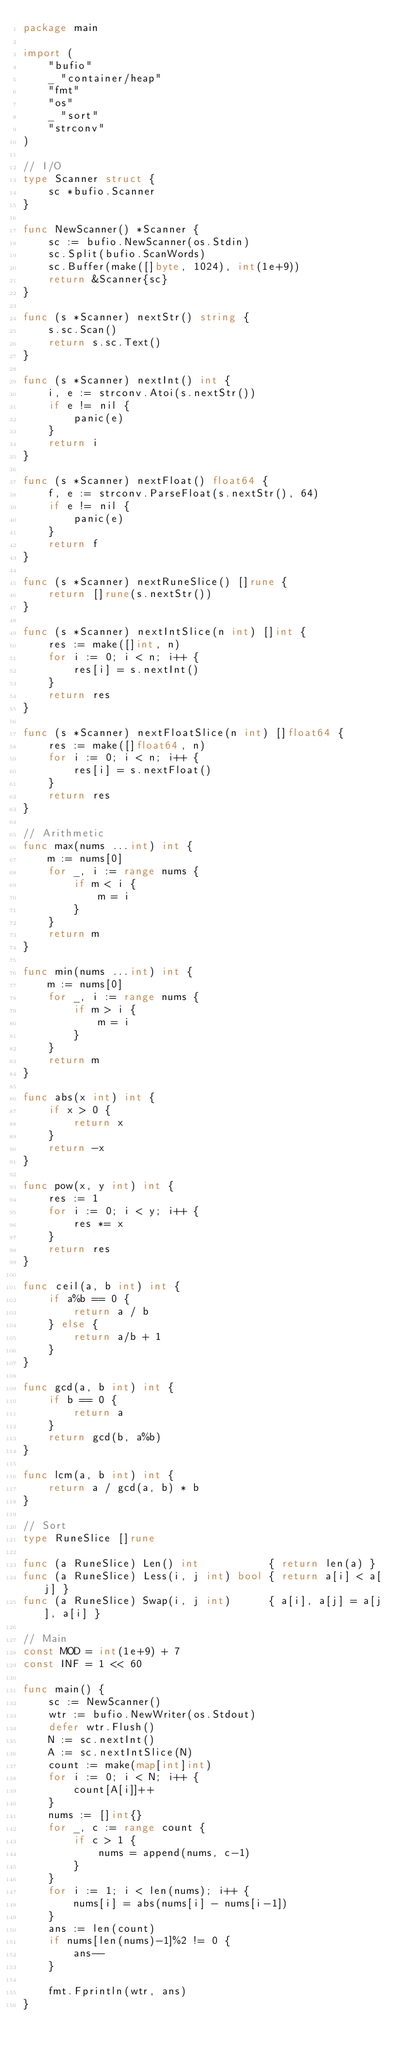<code> <loc_0><loc_0><loc_500><loc_500><_Go_>package main

import (
	"bufio"
	_ "container/heap"
	"fmt"
	"os"
	_ "sort"
	"strconv"
)

// I/O
type Scanner struct {
	sc *bufio.Scanner
}

func NewScanner() *Scanner {
	sc := bufio.NewScanner(os.Stdin)
	sc.Split(bufio.ScanWords)
	sc.Buffer(make([]byte, 1024), int(1e+9))
	return &Scanner{sc}
}

func (s *Scanner) nextStr() string {
	s.sc.Scan()
	return s.sc.Text()
}

func (s *Scanner) nextInt() int {
	i, e := strconv.Atoi(s.nextStr())
	if e != nil {
		panic(e)
	}
	return i
}

func (s *Scanner) nextFloat() float64 {
	f, e := strconv.ParseFloat(s.nextStr(), 64)
	if e != nil {
		panic(e)
	}
	return f
}

func (s *Scanner) nextRuneSlice() []rune {
	return []rune(s.nextStr())
}

func (s *Scanner) nextIntSlice(n int) []int {
	res := make([]int, n)
	for i := 0; i < n; i++ {
		res[i] = s.nextInt()
	}
	return res
}

func (s *Scanner) nextFloatSlice(n int) []float64 {
	res := make([]float64, n)
	for i := 0; i < n; i++ {
		res[i] = s.nextFloat()
	}
	return res
}

// Arithmetic
func max(nums ...int) int {
	m := nums[0]
	for _, i := range nums {
		if m < i {
			m = i
		}
	}
	return m
}

func min(nums ...int) int {
	m := nums[0]
	for _, i := range nums {
		if m > i {
			m = i
		}
	}
	return m
}

func abs(x int) int {
	if x > 0 {
		return x
	}
	return -x
}

func pow(x, y int) int {
	res := 1
	for i := 0; i < y; i++ {
		res *= x
	}
	return res
}

func ceil(a, b int) int {
	if a%b == 0 {
		return a / b
	} else {
		return a/b + 1
	}
}

func gcd(a, b int) int {
	if b == 0 {
		return a
	}
	return gcd(b, a%b)
}

func lcm(a, b int) int {
	return a / gcd(a, b) * b
}

// Sort
type RuneSlice []rune

func (a RuneSlice) Len() int           { return len(a) }
func (a RuneSlice) Less(i, j int) bool { return a[i] < a[j] }
func (a RuneSlice) Swap(i, j int)      { a[i], a[j] = a[j], a[i] }

// Main
const MOD = int(1e+9) + 7
const INF = 1 << 60

func main() {
	sc := NewScanner()
	wtr := bufio.NewWriter(os.Stdout)
	defer wtr.Flush()
	N := sc.nextInt()
	A := sc.nextIntSlice(N)
	count := make(map[int]int)
	for i := 0; i < N; i++ {
		count[A[i]]++
	}
	nums := []int{}
	for _, c := range count {
		if c > 1 {
			nums = append(nums, c-1)
		}
	}
	for i := 1; i < len(nums); i++ {
		nums[i] = abs(nums[i] - nums[i-1])
	}
	ans := len(count)
	if nums[len(nums)-1]%2 != 0 {
		ans--
	}

	fmt.Fprintln(wtr, ans)
}
</code> 